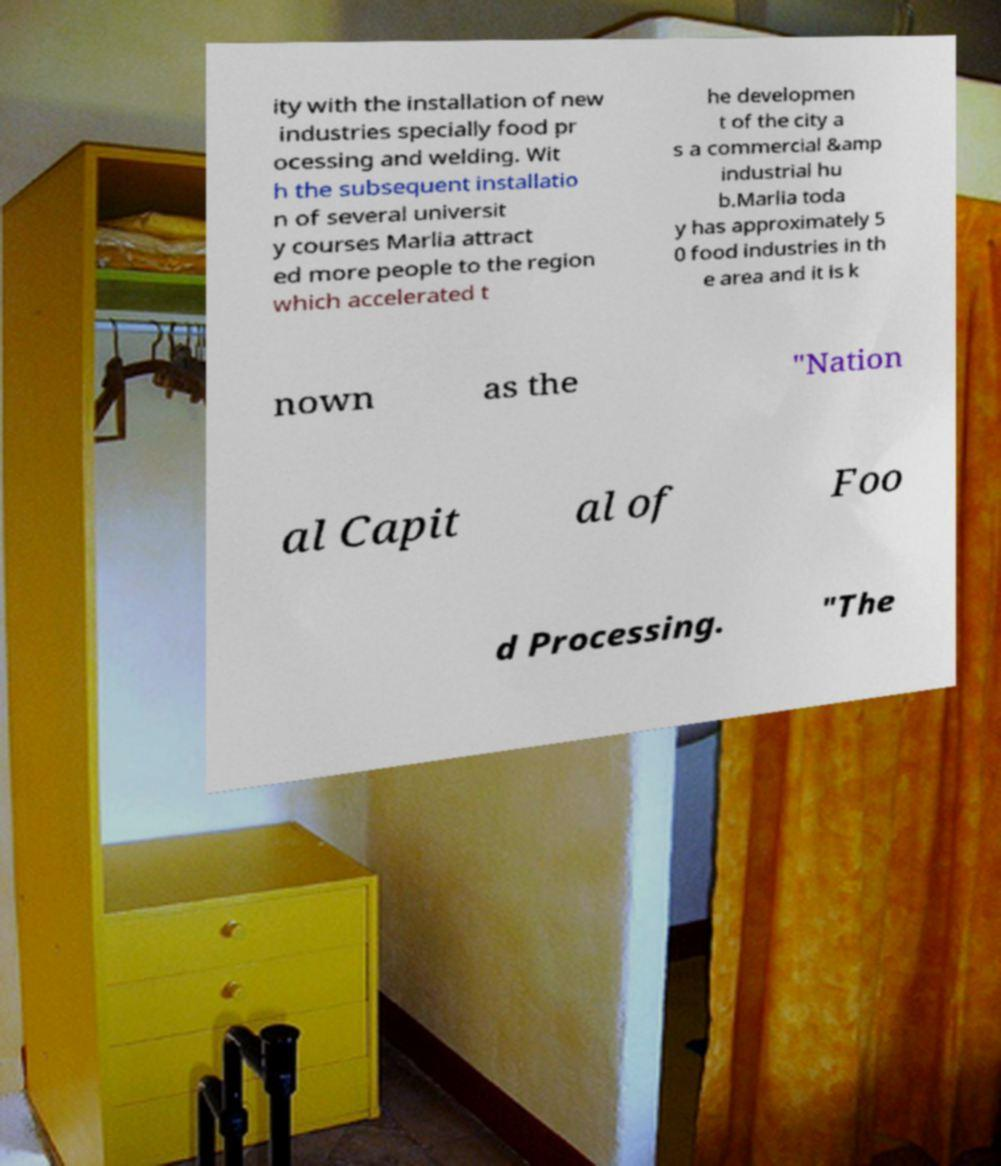Please identify and transcribe the text found in this image. ity with the installation of new industries specially food pr ocessing and welding. Wit h the subsequent installatio n of several universit y courses Marlia attract ed more people to the region which accelerated t he developmen t of the city a s a commercial &amp industrial hu b.Marlia toda y has approximately 5 0 food industries in th e area and it is k nown as the "Nation al Capit al of Foo d Processing. "The 